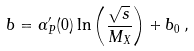Convert formula to latex. <formula><loc_0><loc_0><loc_500><loc_500>b = \alpha ^ { \prime } _ { P } ( 0 ) \ln \left ( \frac { \sqrt { s } } { M _ { X } } \right ) + b _ { 0 } \, ,</formula> 